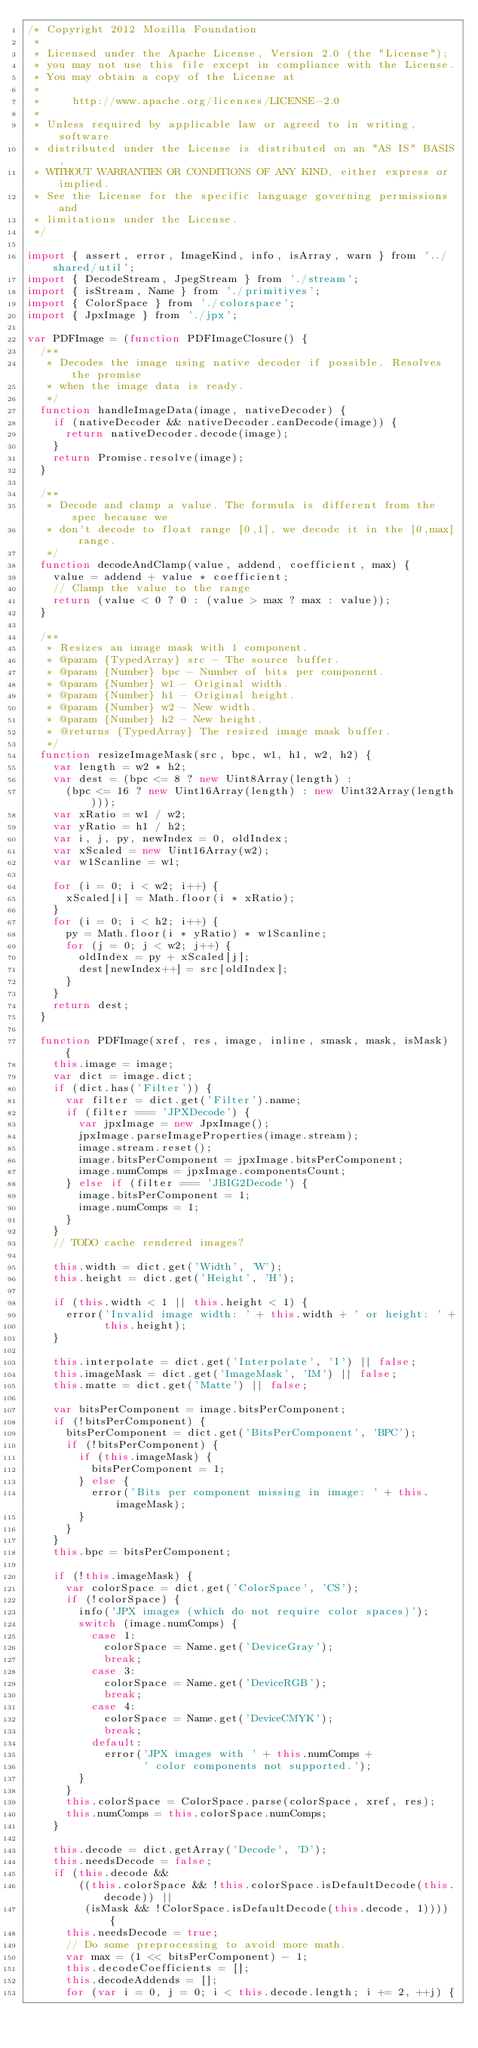Convert code to text. <code><loc_0><loc_0><loc_500><loc_500><_JavaScript_>/* Copyright 2012 Mozilla Foundation
 *
 * Licensed under the Apache License, Version 2.0 (the "License");
 * you may not use this file except in compliance with the License.
 * You may obtain a copy of the License at
 *
 *     http://www.apache.org/licenses/LICENSE-2.0
 *
 * Unless required by applicable law or agreed to in writing, software
 * distributed under the License is distributed on an "AS IS" BASIS,
 * WITHOUT WARRANTIES OR CONDITIONS OF ANY KIND, either express or implied.
 * See the License for the specific language governing permissions and
 * limitations under the License.
 */

import { assert, error, ImageKind, info, isArray, warn } from '../shared/util';
import { DecodeStream, JpegStream } from './stream';
import { isStream, Name } from './primitives';
import { ColorSpace } from './colorspace';
import { JpxImage } from './jpx';

var PDFImage = (function PDFImageClosure() {
  /**
   * Decodes the image using native decoder if possible. Resolves the promise
   * when the image data is ready.
   */
  function handleImageData(image, nativeDecoder) {
    if (nativeDecoder && nativeDecoder.canDecode(image)) {
      return nativeDecoder.decode(image);
    }
    return Promise.resolve(image);
  }

  /**
   * Decode and clamp a value. The formula is different from the spec because we
   * don't decode to float range [0,1], we decode it in the [0,max] range.
   */
  function decodeAndClamp(value, addend, coefficient, max) {
    value = addend + value * coefficient;
    // Clamp the value to the range
    return (value < 0 ? 0 : (value > max ? max : value));
  }

  /**
   * Resizes an image mask with 1 component.
   * @param {TypedArray} src - The source buffer.
   * @param {Number} bpc - Number of bits per component.
   * @param {Number} w1 - Original width.
   * @param {Number} h1 - Original height.
   * @param {Number} w2 - New width.
   * @param {Number} h2 - New height.
   * @returns {TypedArray} The resized image mask buffer.
   */
  function resizeImageMask(src, bpc, w1, h1, w2, h2) {
    var length = w2 * h2;
    var dest = (bpc <= 8 ? new Uint8Array(length) :
      (bpc <= 16 ? new Uint16Array(length) : new Uint32Array(length)));
    var xRatio = w1 / w2;
    var yRatio = h1 / h2;
    var i, j, py, newIndex = 0, oldIndex;
    var xScaled = new Uint16Array(w2);
    var w1Scanline = w1;

    for (i = 0; i < w2; i++) {
      xScaled[i] = Math.floor(i * xRatio);
    }
    for (i = 0; i < h2; i++) {
      py = Math.floor(i * yRatio) * w1Scanline;
      for (j = 0; j < w2; j++) {
        oldIndex = py + xScaled[j];
        dest[newIndex++] = src[oldIndex];
      }
    }
    return dest;
  }

  function PDFImage(xref, res, image, inline, smask, mask, isMask) {
    this.image = image;
    var dict = image.dict;
    if (dict.has('Filter')) {
      var filter = dict.get('Filter').name;
      if (filter === 'JPXDecode') {
        var jpxImage = new JpxImage();
        jpxImage.parseImageProperties(image.stream);
        image.stream.reset();
        image.bitsPerComponent = jpxImage.bitsPerComponent;
        image.numComps = jpxImage.componentsCount;
      } else if (filter === 'JBIG2Decode') {
        image.bitsPerComponent = 1;
        image.numComps = 1;
      }
    }
    // TODO cache rendered images?

    this.width = dict.get('Width', 'W');
    this.height = dict.get('Height', 'H');

    if (this.width < 1 || this.height < 1) {
      error('Invalid image width: ' + this.width + ' or height: ' +
            this.height);
    }

    this.interpolate = dict.get('Interpolate', 'I') || false;
    this.imageMask = dict.get('ImageMask', 'IM') || false;
    this.matte = dict.get('Matte') || false;

    var bitsPerComponent = image.bitsPerComponent;
    if (!bitsPerComponent) {
      bitsPerComponent = dict.get('BitsPerComponent', 'BPC');
      if (!bitsPerComponent) {
        if (this.imageMask) {
          bitsPerComponent = 1;
        } else {
          error('Bits per component missing in image: ' + this.imageMask);
        }
      }
    }
    this.bpc = bitsPerComponent;

    if (!this.imageMask) {
      var colorSpace = dict.get('ColorSpace', 'CS');
      if (!colorSpace) {
        info('JPX images (which do not require color spaces)');
        switch (image.numComps) {
          case 1:
            colorSpace = Name.get('DeviceGray');
            break;
          case 3:
            colorSpace = Name.get('DeviceRGB');
            break;
          case 4:
            colorSpace = Name.get('DeviceCMYK');
            break;
          default:
            error('JPX images with ' + this.numComps +
                  ' color components not supported.');
        }
      }
      this.colorSpace = ColorSpace.parse(colorSpace, xref, res);
      this.numComps = this.colorSpace.numComps;
    }

    this.decode = dict.getArray('Decode', 'D');
    this.needsDecode = false;
    if (this.decode &&
        ((this.colorSpace && !this.colorSpace.isDefaultDecode(this.decode)) ||
         (isMask && !ColorSpace.isDefaultDecode(this.decode, 1)))) {
      this.needsDecode = true;
      // Do some preprocessing to avoid more math.
      var max = (1 << bitsPerComponent) - 1;
      this.decodeCoefficients = [];
      this.decodeAddends = [];
      for (var i = 0, j = 0; i < this.decode.length; i += 2, ++j) {</code> 